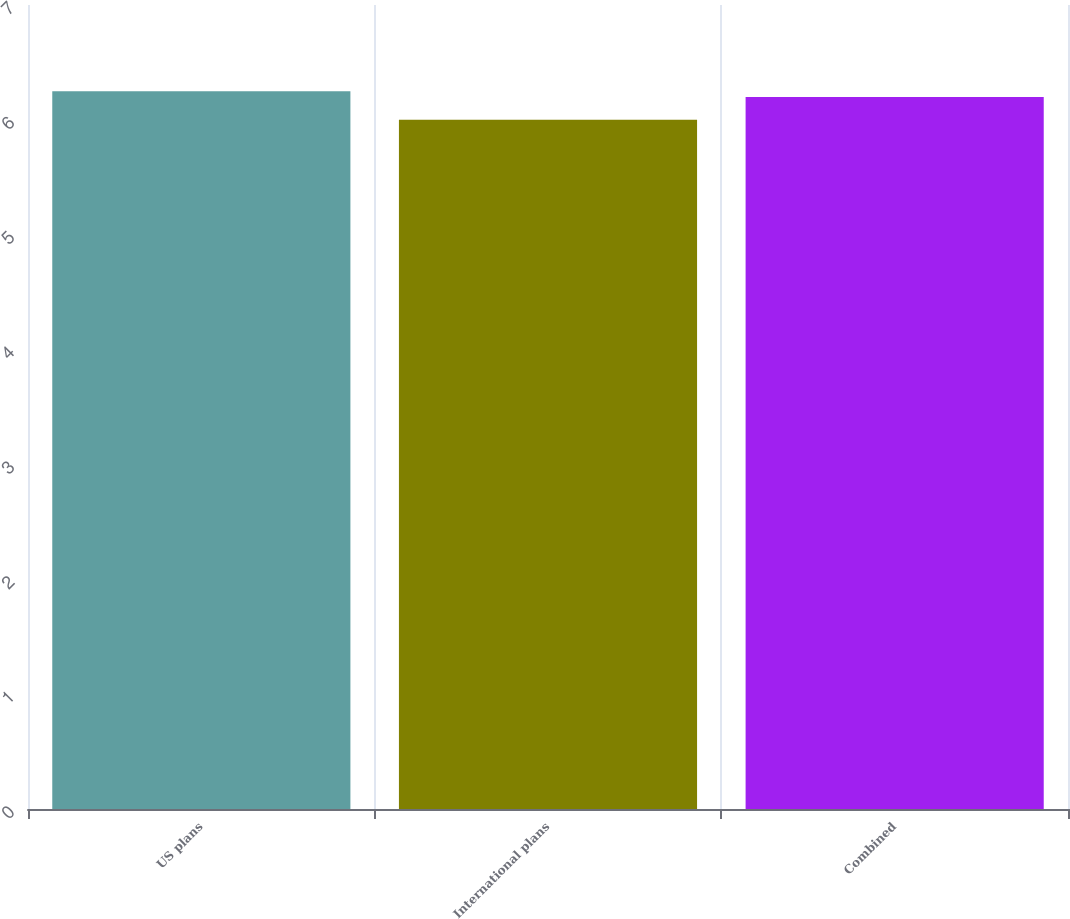<chart> <loc_0><loc_0><loc_500><loc_500><bar_chart><fcel>US plans<fcel>International plans<fcel>Combined<nl><fcel>6.25<fcel>6<fcel>6.2<nl></chart> 